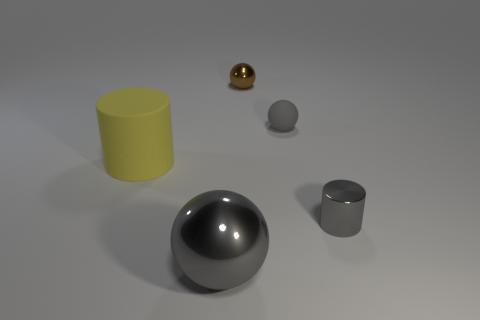Is the color of the metallic sphere in front of the gray matte ball the same as the small rubber sphere?
Your answer should be very brief. Yes. There is a small thing that is the same color as the rubber sphere; what shape is it?
Make the answer very short. Cylinder. What number of large things are either rubber things or brown metal blocks?
Keep it short and to the point. 1. Is the number of large gray metallic objects that are behind the rubber sphere greater than the number of small metal things that are in front of the big yellow matte cylinder?
Your response must be concise. No. What size is the shiny object that is the same color as the big metal ball?
Give a very brief answer. Small. What number of other objects are the same size as the gray shiny ball?
Offer a very short reply. 1. Is the material of the cylinder right of the large ball the same as the small brown ball?
Offer a very short reply. Yes. How many other things are the same color as the big ball?
Offer a terse response. 2. What number of other things are the same shape as the large shiny object?
Ensure brevity in your answer.  2. There is a small thing on the left side of the small gray ball; is its shape the same as the tiny thing that is in front of the yellow matte cylinder?
Ensure brevity in your answer.  No. 